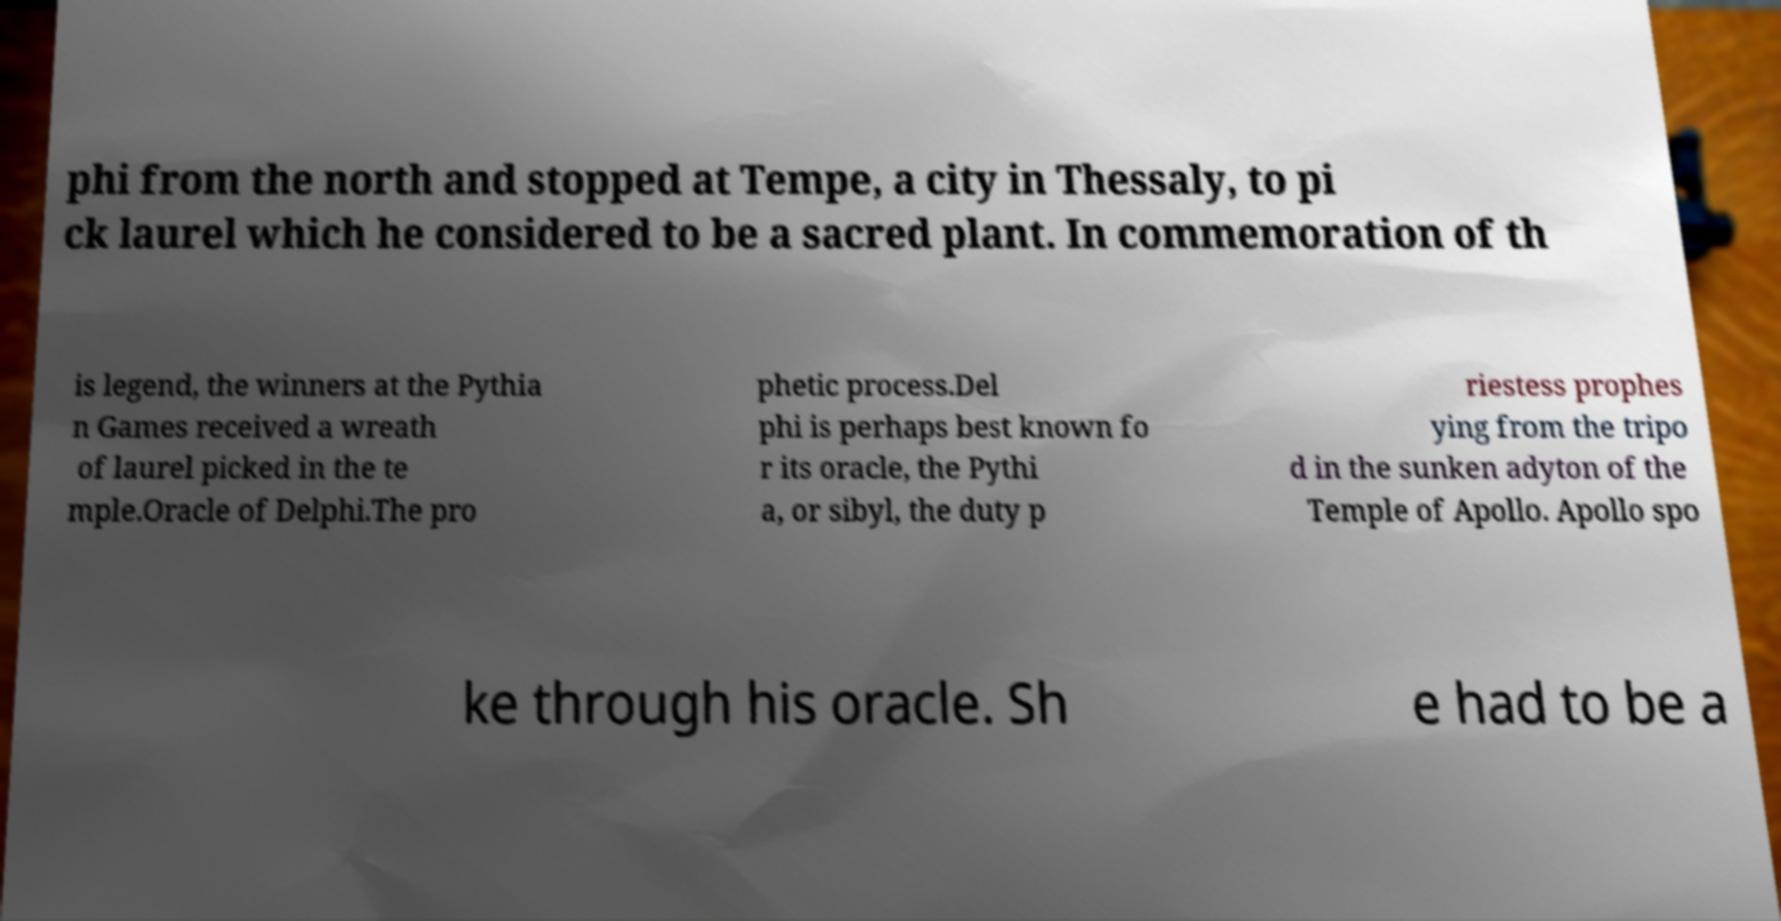Please identify and transcribe the text found in this image. phi from the north and stopped at Tempe, a city in Thessaly, to pi ck laurel which he considered to be a sacred plant. In commemoration of th is legend, the winners at the Pythia n Games received a wreath of laurel picked in the te mple.Oracle of Delphi.The pro phetic process.Del phi is perhaps best known fo r its oracle, the Pythi a, or sibyl, the duty p riestess prophes ying from the tripo d in the sunken adyton of the Temple of Apollo. Apollo spo ke through his oracle. Sh e had to be a 